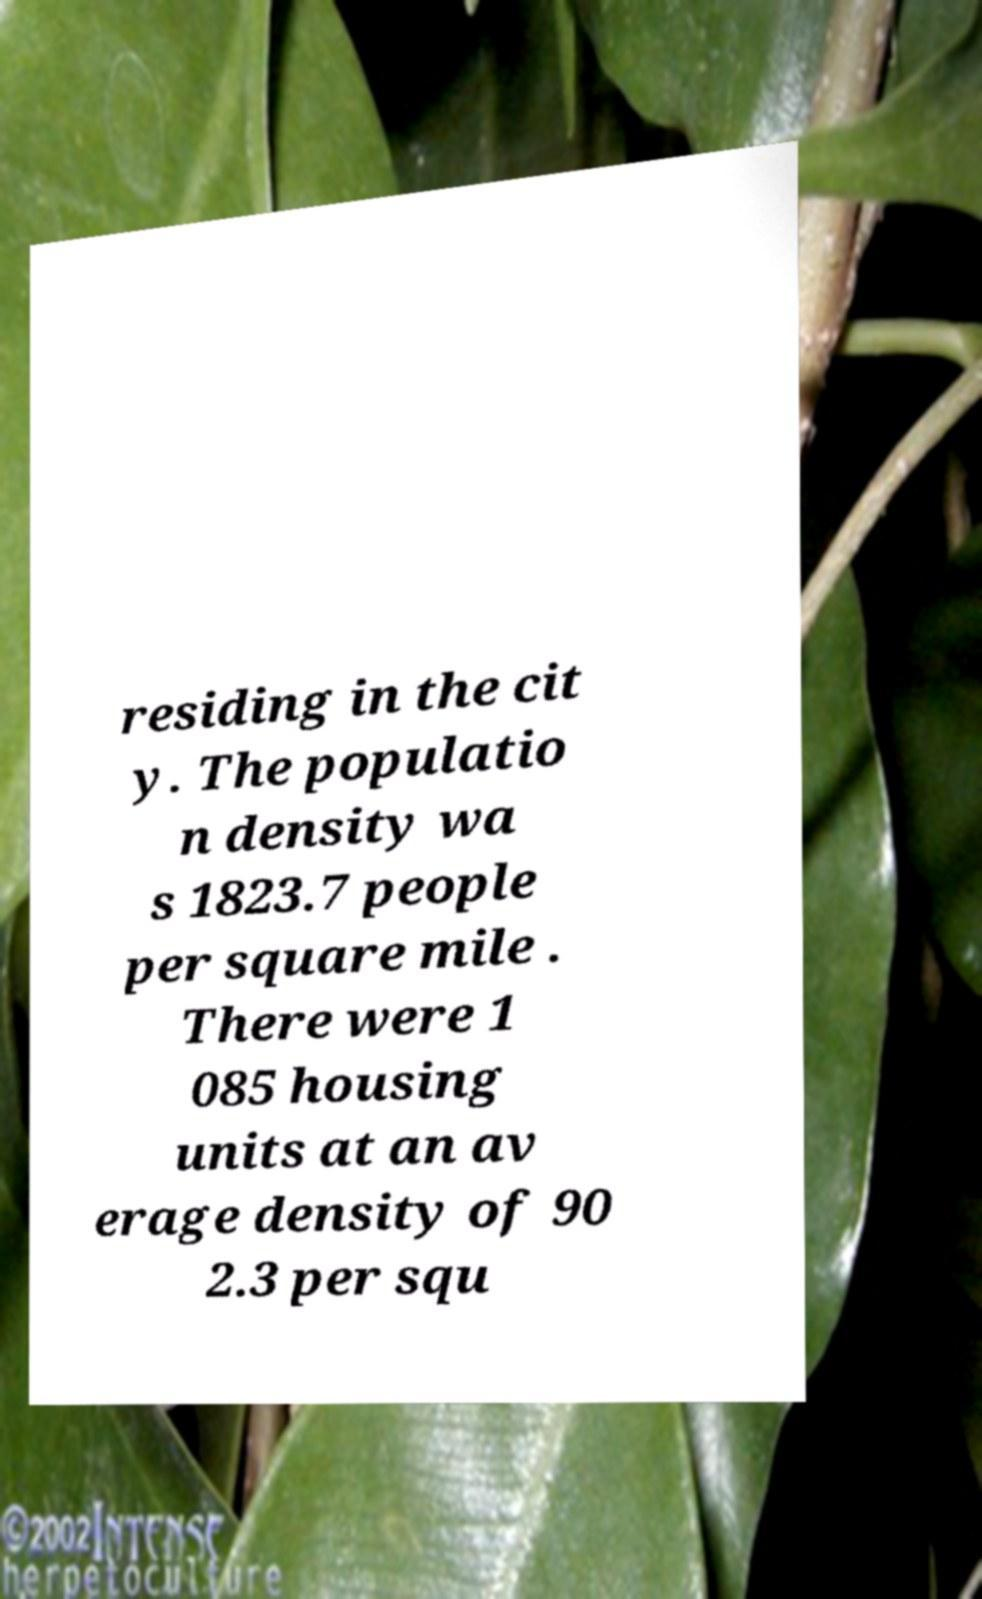Can you read and provide the text displayed in the image?This photo seems to have some interesting text. Can you extract and type it out for me? residing in the cit y. The populatio n density wa s 1823.7 people per square mile . There were 1 085 housing units at an av erage density of 90 2.3 per squ 